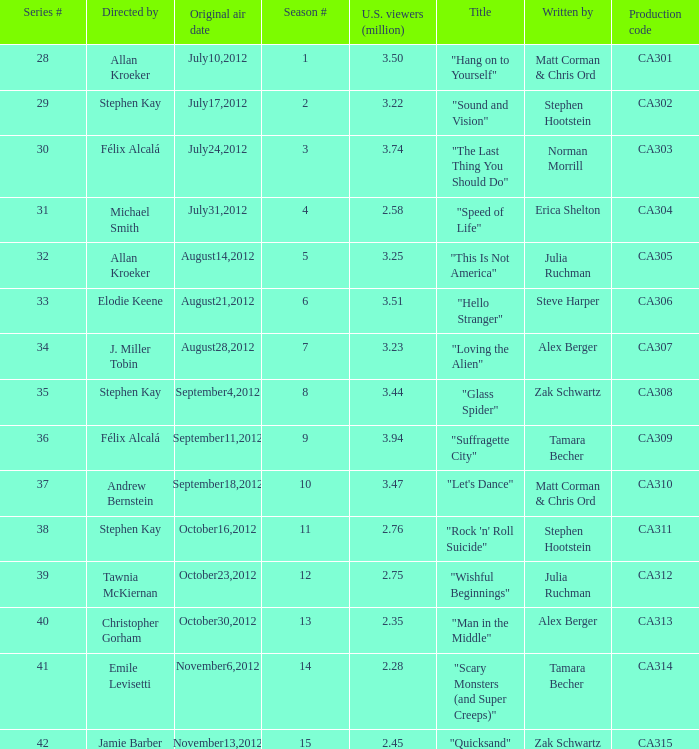What is the series episode number of the episode titled "sound and vision"? 29.0. 